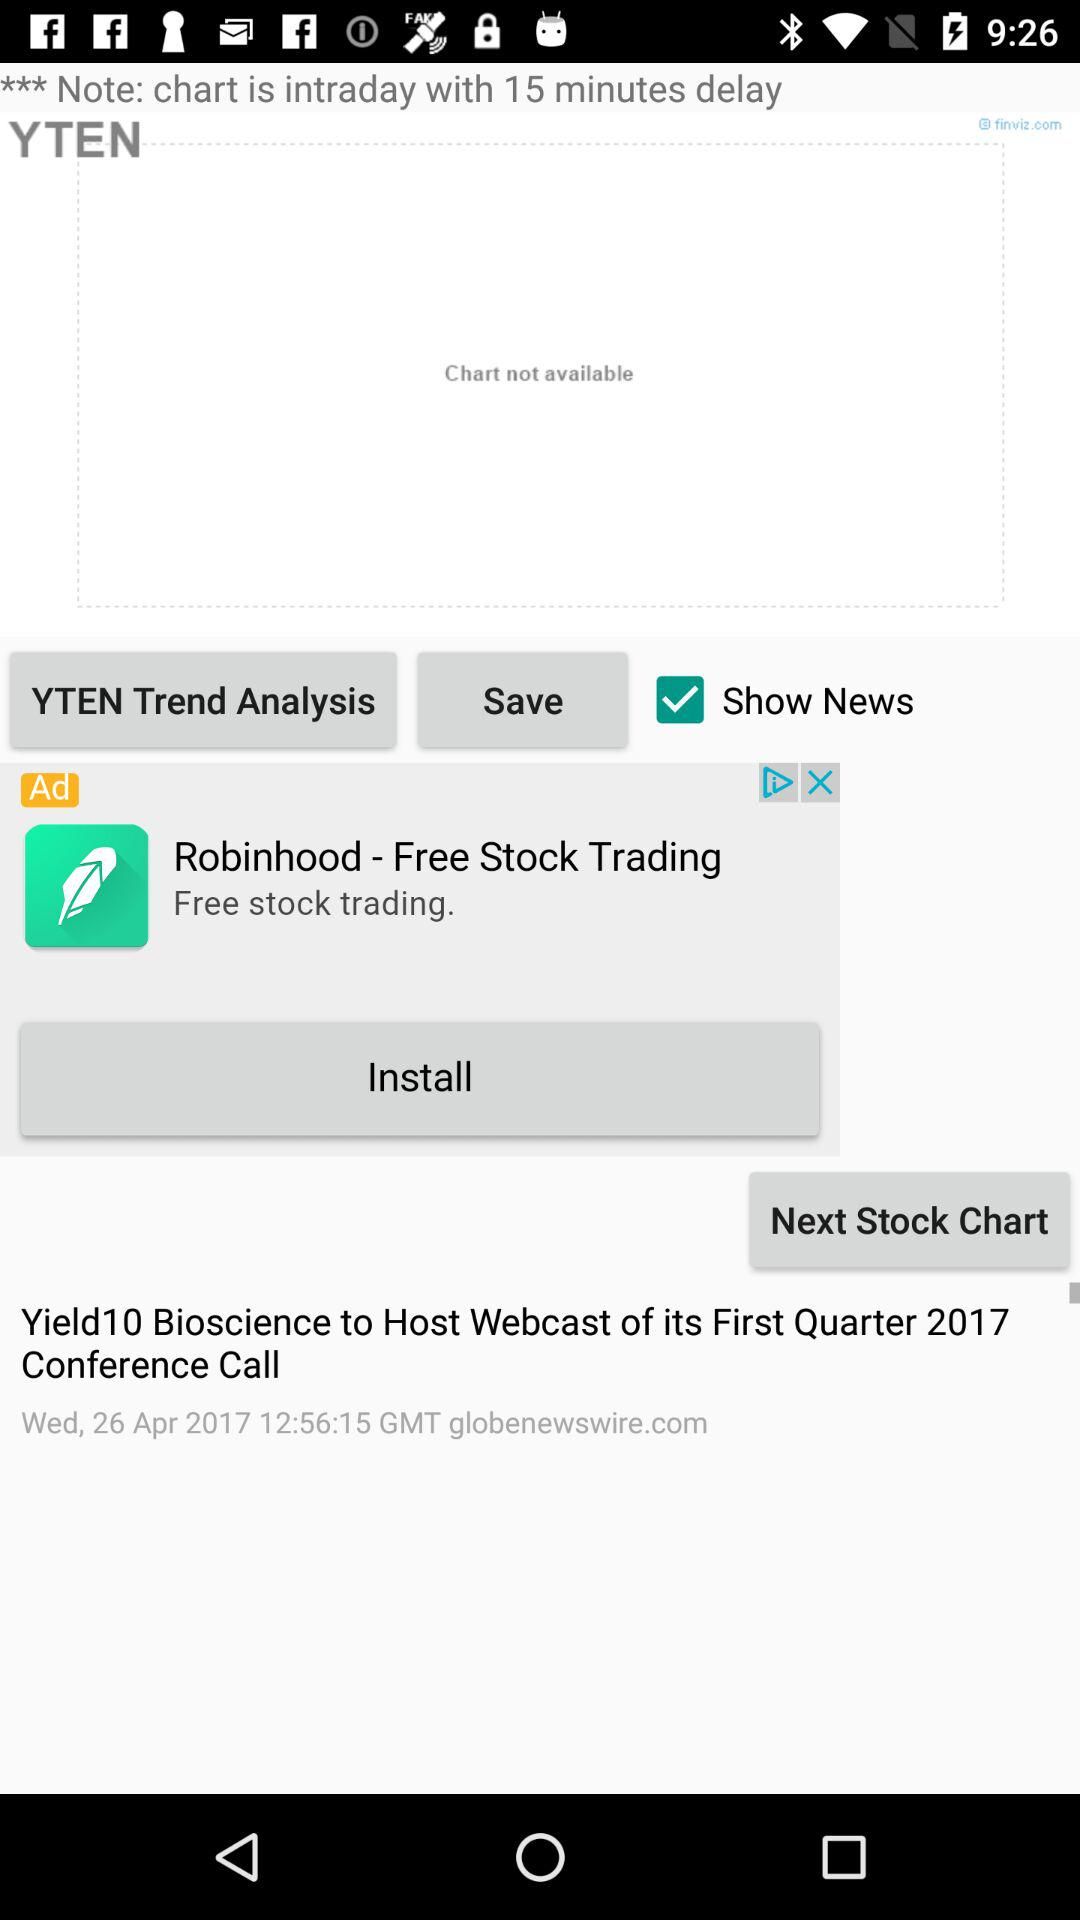Which day falls on 26th of April 2017? The day is Wednesday. 